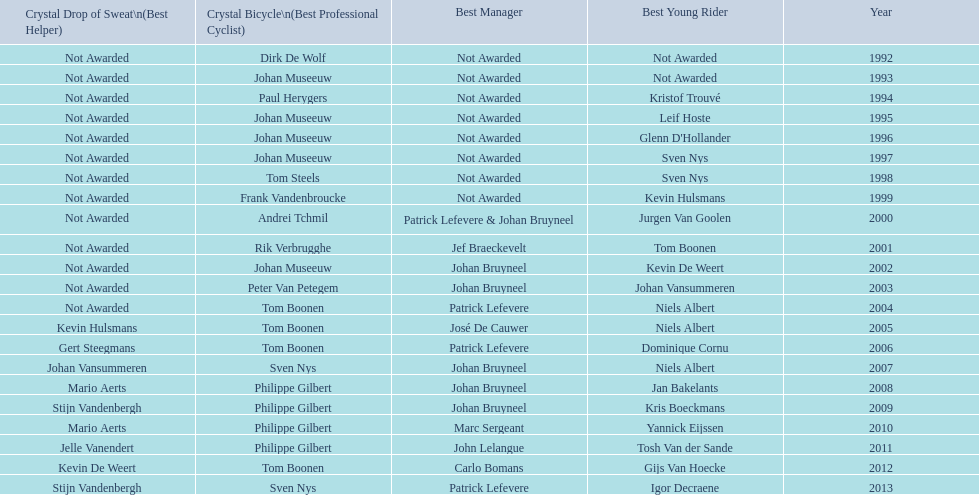Who won the most consecutive crystal bicycles? Philippe Gilbert. 